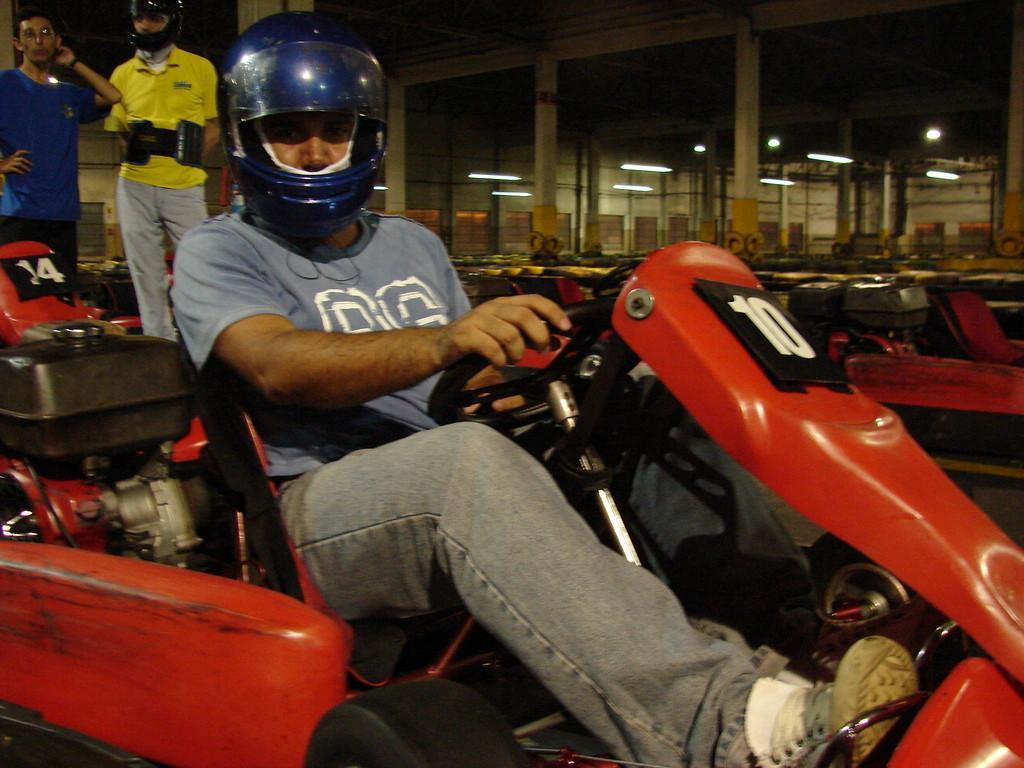In one or two sentences, can you explain what this image depicts? There is a man sitting on go kart vehicle and he is wearing a helmet. In the background there are two man standing on the left side. 